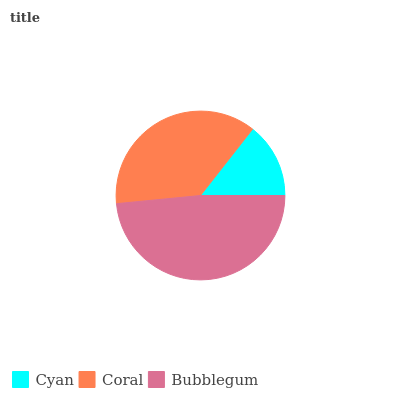Is Cyan the minimum?
Answer yes or no. Yes. Is Bubblegum the maximum?
Answer yes or no. Yes. Is Coral the minimum?
Answer yes or no. No. Is Coral the maximum?
Answer yes or no. No. Is Coral greater than Cyan?
Answer yes or no. Yes. Is Cyan less than Coral?
Answer yes or no. Yes. Is Cyan greater than Coral?
Answer yes or no. No. Is Coral less than Cyan?
Answer yes or no. No. Is Coral the high median?
Answer yes or no. Yes. Is Coral the low median?
Answer yes or no. Yes. Is Cyan the high median?
Answer yes or no. No. Is Bubblegum the low median?
Answer yes or no. No. 